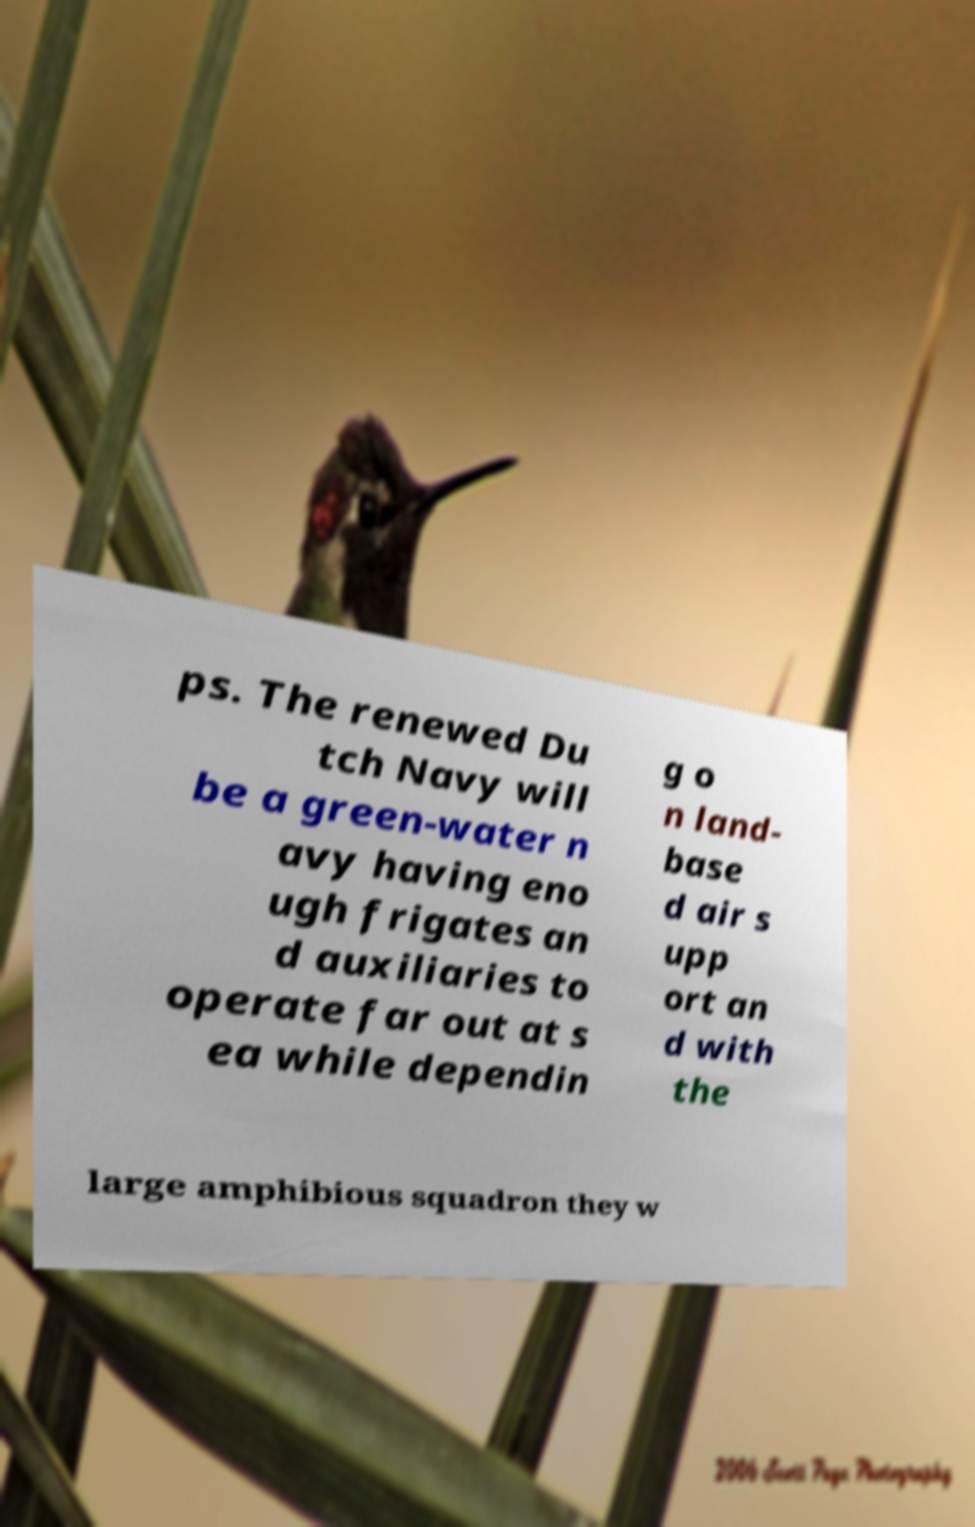What messages or text are displayed in this image? I need them in a readable, typed format. ps. The renewed Du tch Navy will be a green-water n avy having eno ugh frigates an d auxiliaries to operate far out at s ea while dependin g o n land- base d air s upp ort an d with the large amphibious squadron they w 